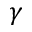<formula> <loc_0><loc_0><loc_500><loc_500>\gamma</formula> 